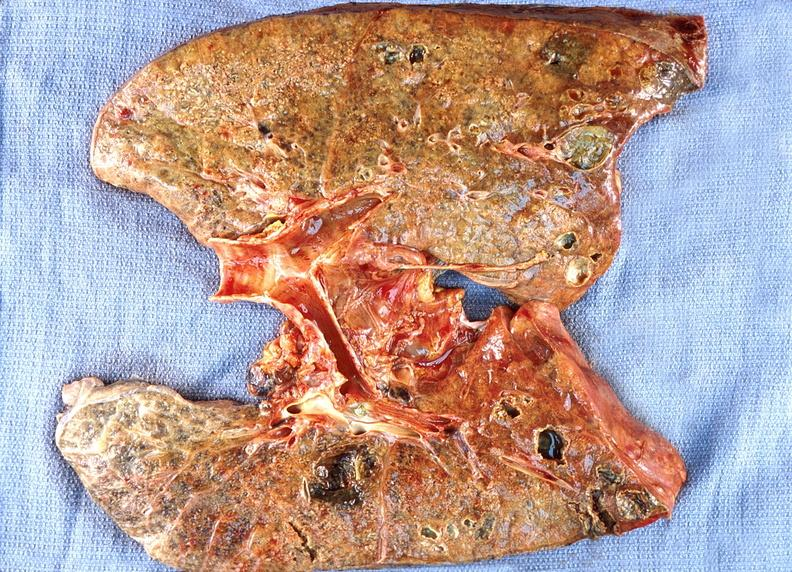s respiratory present?
Answer the question using a single word or phrase. Yes 